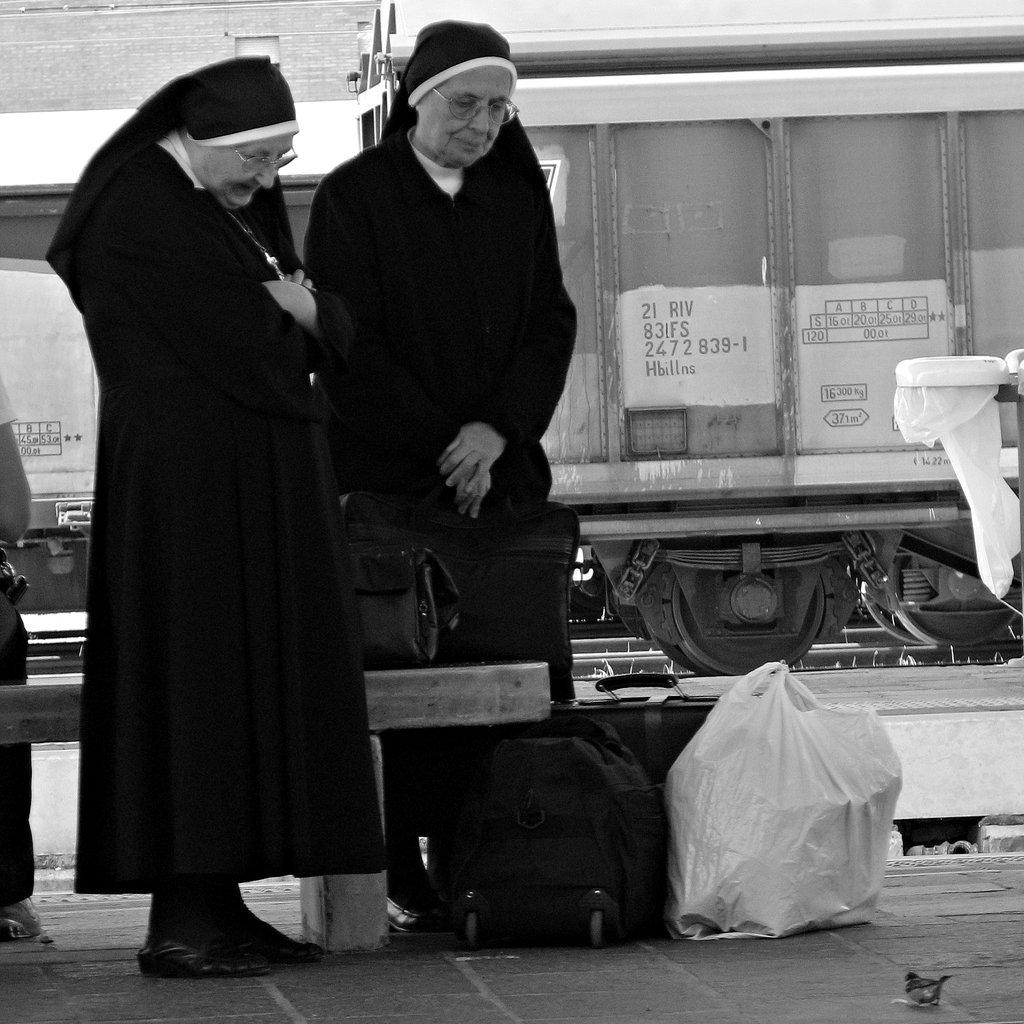How many people are present in the image? There are two persons standing in the image. What are the people holding or carrying in the image? There are bags in the image. What can be seen in the background of the image? There is a vehicle in the background of the image. What is on the floor in the image? There are objects on the floor in the image. Can you tell me how many donkeys are visible in the image? There are no donkeys present in the image. What level of detail can be seen on the objects on the floor? The provided facts do not mention the level of detail on the objects on the floor, so it cannot be determined from the image. 